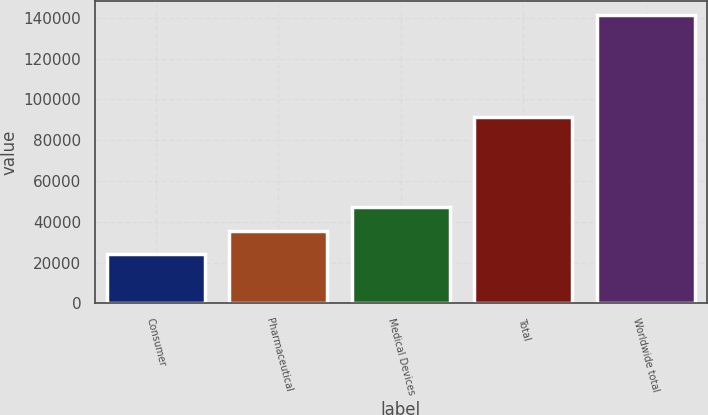Convert chart to OTSL. <chart><loc_0><loc_0><loc_500><loc_500><bar_chart><fcel>Consumer<fcel>Pharmaceutical<fcel>Medical Devices<fcel>Total<fcel>Worldwide total<nl><fcel>23971<fcel>35694.7<fcel>47418.4<fcel>91221<fcel>141208<nl></chart> 